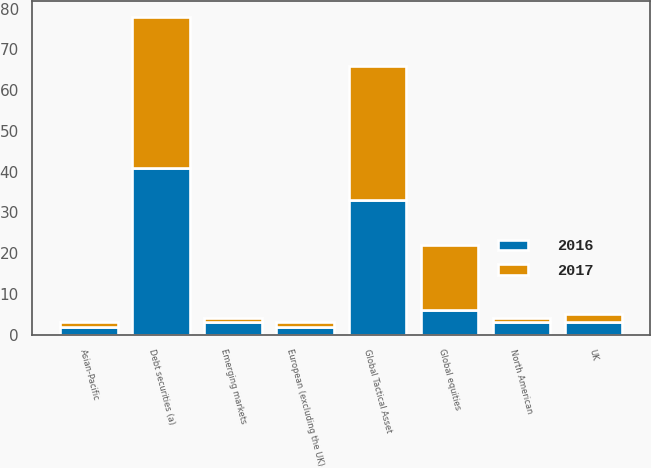Convert chart. <chart><loc_0><loc_0><loc_500><loc_500><stacked_bar_chart><ecel><fcel>UK<fcel>European (excluding the UK)<fcel>Asian-Pacific<fcel>North American<fcel>Emerging markets<fcel>Global equities<fcel>Global Tactical Asset<fcel>Debt securities (a)<nl><fcel>2017<fcel>2<fcel>1<fcel>1<fcel>1<fcel>1<fcel>16<fcel>33<fcel>37<nl><fcel>2016<fcel>3<fcel>2<fcel>2<fcel>3<fcel>3<fcel>6<fcel>33<fcel>41<nl></chart> 